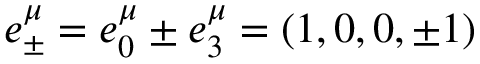<formula> <loc_0><loc_0><loc_500><loc_500>e _ { \pm } ^ { \mu } = e _ { 0 } ^ { \mu } \pm e _ { 3 } ^ { \mu } = \left ( 1 , 0 , 0 , \pm 1 \right )</formula> 